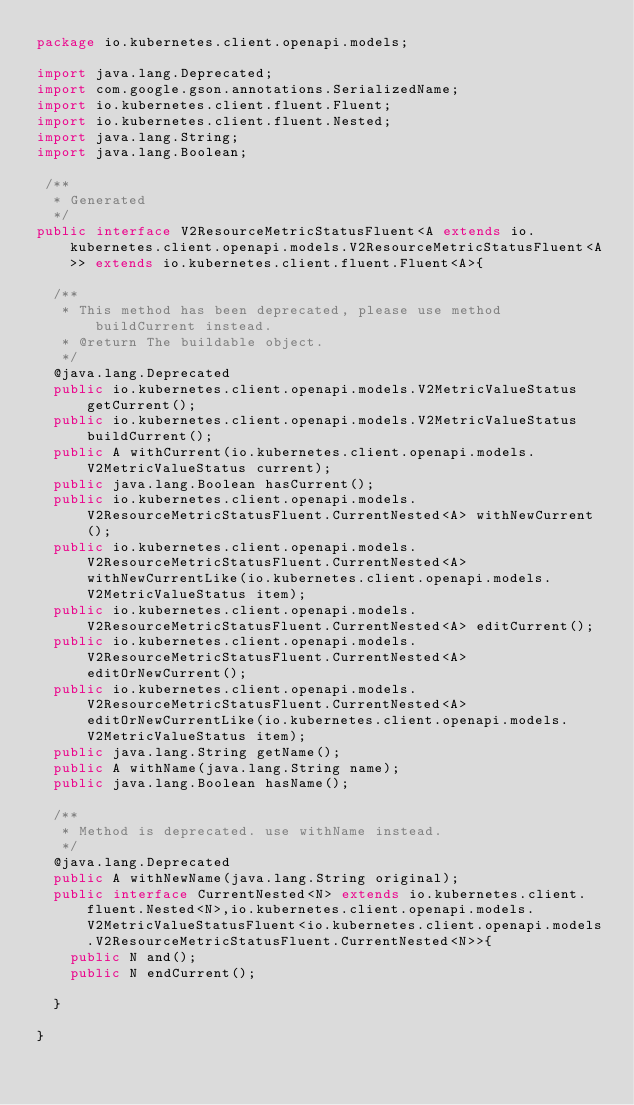<code> <loc_0><loc_0><loc_500><loc_500><_Java_>package io.kubernetes.client.openapi.models;

import java.lang.Deprecated;
import com.google.gson.annotations.SerializedName;
import io.kubernetes.client.fluent.Fluent;
import io.kubernetes.client.fluent.Nested;
import java.lang.String;
import java.lang.Boolean;

 /**
  * Generated
  */
public interface V2ResourceMetricStatusFluent<A extends io.kubernetes.client.openapi.models.V2ResourceMetricStatusFluent<A>> extends io.kubernetes.client.fluent.Fluent<A>{
  
  /**
   * This method has been deprecated, please use method buildCurrent instead.
   * @return The buildable object.
   */
  @java.lang.Deprecated
  public io.kubernetes.client.openapi.models.V2MetricValueStatus getCurrent();
  public io.kubernetes.client.openapi.models.V2MetricValueStatus buildCurrent();
  public A withCurrent(io.kubernetes.client.openapi.models.V2MetricValueStatus current);
  public java.lang.Boolean hasCurrent();
  public io.kubernetes.client.openapi.models.V2ResourceMetricStatusFluent.CurrentNested<A> withNewCurrent();
  public io.kubernetes.client.openapi.models.V2ResourceMetricStatusFluent.CurrentNested<A> withNewCurrentLike(io.kubernetes.client.openapi.models.V2MetricValueStatus item);
  public io.kubernetes.client.openapi.models.V2ResourceMetricStatusFluent.CurrentNested<A> editCurrent();
  public io.kubernetes.client.openapi.models.V2ResourceMetricStatusFluent.CurrentNested<A> editOrNewCurrent();
  public io.kubernetes.client.openapi.models.V2ResourceMetricStatusFluent.CurrentNested<A> editOrNewCurrentLike(io.kubernetes.client.openapi.models.V2MetricValueStatus item);
  public java.lang.String getName();
  public A withName(java.lang.String name);
  public java.lang.Boolean hasName();
  
  /**
   * Method is deprecated. use withName instead.
   */
  @java.lang.Deprecated
  public A withNewName(java.lang.String original);
  public interface CurrentNested<N> extends io.kubernetes.client.fluent.Nested<N>,io.kubernetes.client.openapi.models.V2MetricValueStatusFluent<io.kubernetes.client.openapi.models.V2ResourceMetricStatusFluent.CurrentNested<N>>{
    public N and();
    public N endCurrent();
    
  }
  
}</code> 